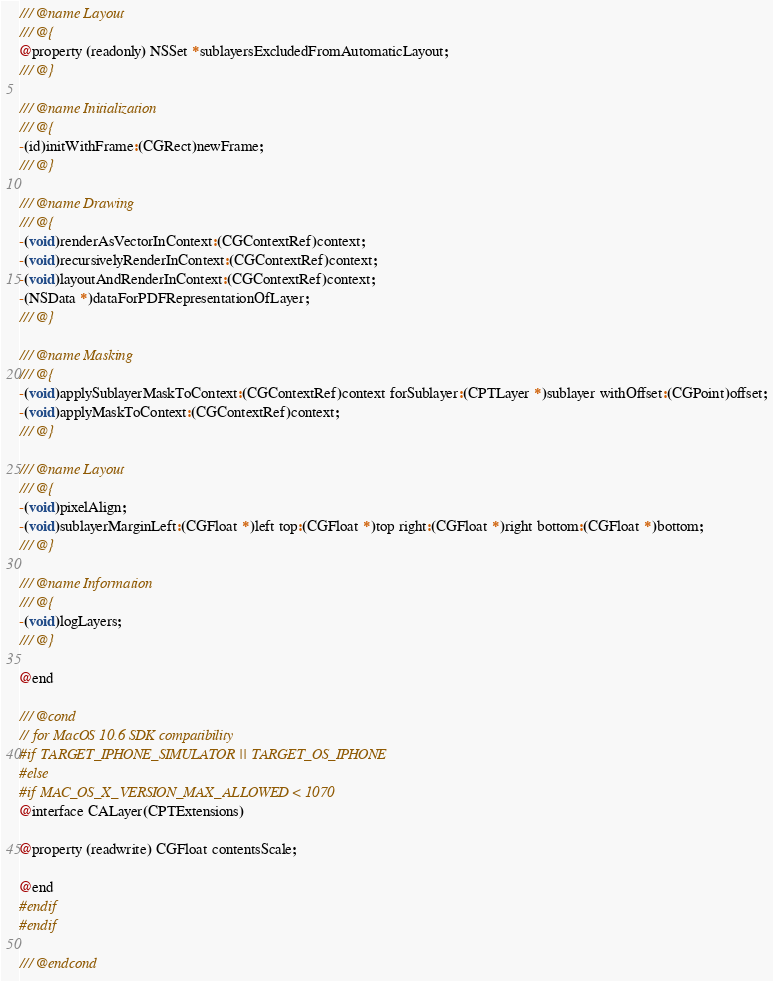<code> <loc_0><loc_0><loc_500><loc_500><_C_>/// @name Layout
/// @{
@property (readonly) NSSet *sublayersExcludedFromAutomaticLayout;
/// @}

/// @name Initialization
/// @{
-(id)initWithFrame:(CGRect)newFrame;
/// @}

/// @name Drawing
/// @{
-(void)renderAsVectorInContext:(CGContextRef)context;
-(void)recursivelyRenderInContext:(CGContextRef)context;
-(void)layoutAndRenderInContext:(CGContextRef)context;
-(NSData *)dataForPDFRepresentationOfLayer;
/// @}

/// @name Masking
/// @{
-(void)applySublayerMaskToContext:(CGContextRef)context forSublayer:(CPTLayer *)sublayer withOffset:(CGPoint)offset;
-(void)applyMaskToContext:(CGContextRef)context;
/// @}

/// @name Layout
/// @{
-(void)pixelAlign;
-(void)sublayerMarginLeft:(CGFloat *)left top:(CGFloat *)top right:(CGFloat *)right bottom:(CGFloat *)bottom;
/// @}

/// @name Information
/// @{
-(void)logLayers;
/// @}

@end

/// @cond
// for MacOS 10.6 SDK compatibility
#if TARGET_IPHONE_SIMULATOR || TARGET_OS_IPHONE
#else
#if MAC_OS_X_VERSION_MAX_ALLOWED < 1070
@interface CALayer(CPTExtensions)

@property (readwrite) CGFloat contentsScale;

@end
#endif
#endif

/// @endcond
</code> 